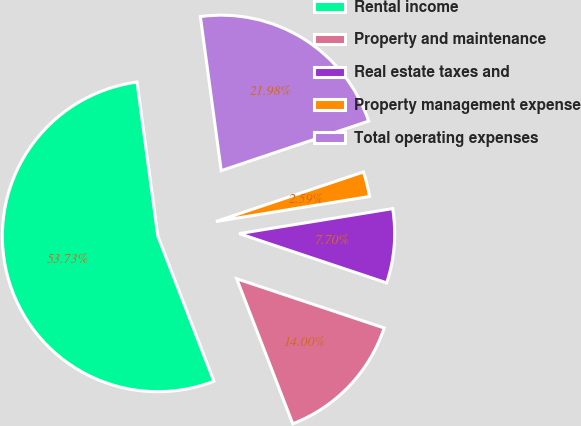<chart> <loc_0><loc_0><loc_500><loc_500><pie_chart><fcel>Rental income<fcel>Property and maintenance<fcel>Real estate taxes and<fcel>Property management expense<fcel>Total operating expenses<nl><fcel>53.73%<fcel>14.0%<fcel>7.7%<fcel>2.59%<fcel>21.98%<nl></chart> 